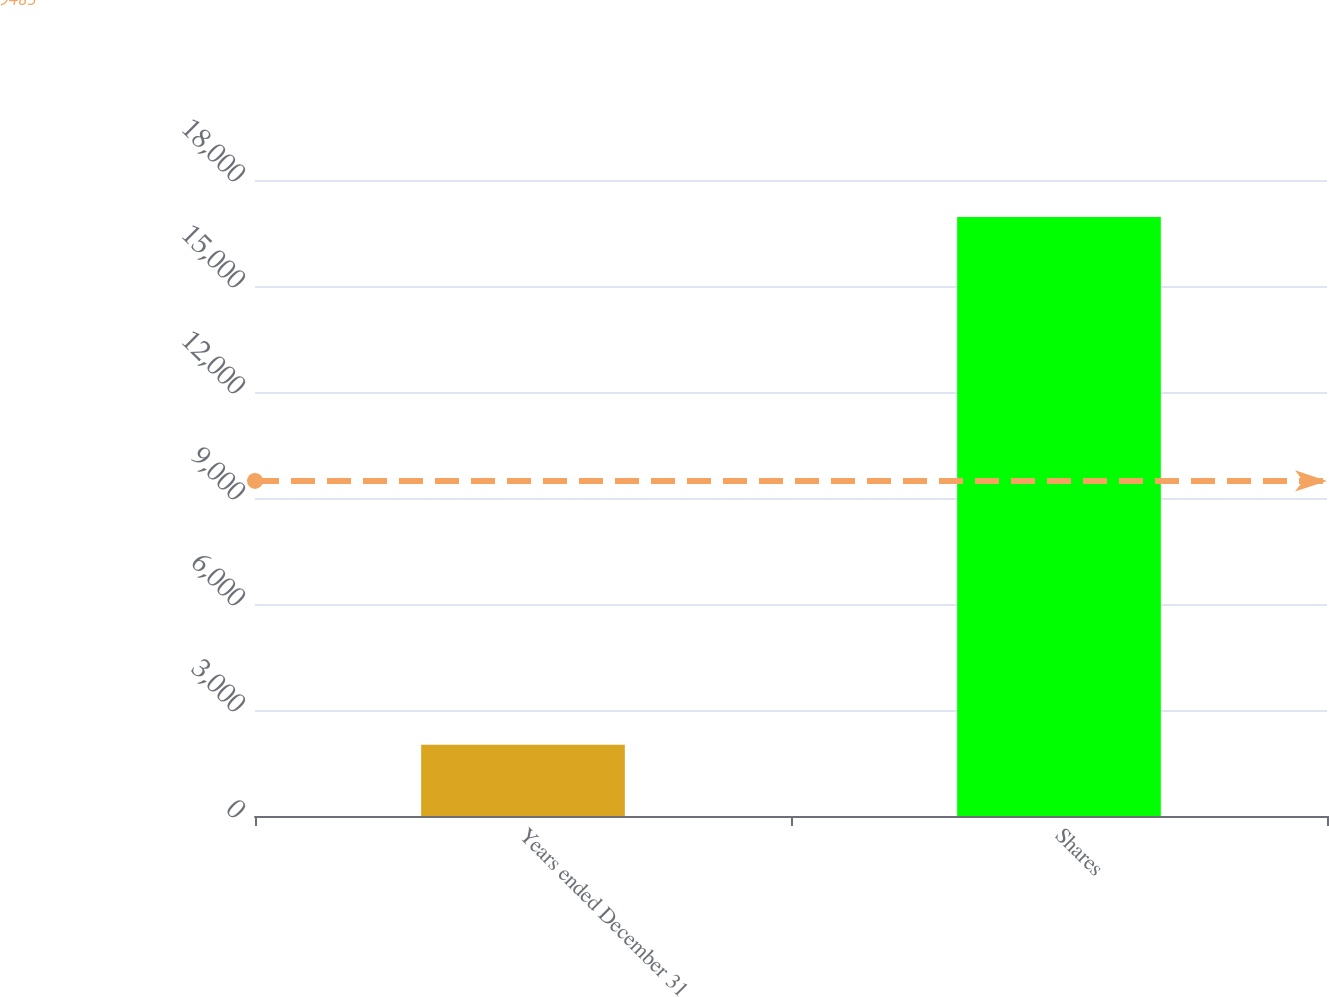Convert chart to OTSL. <chart><loc_0><loc_0><loc_500><loc_500><bar_chart><fcel>Years ended December 31<fcel>Shares<nl><fcel>2014<fcel>16952<nl></chart> 